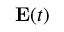<formula> <loc_0><loc_0><loc_500><loc_500>E ( t )</formula> 